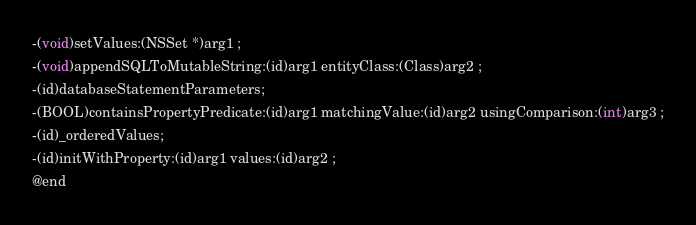<code> <loc_0><loc_0><loc_500><loc_500><_C_>-(void)setValues:(NSSet *)arg1 ;
-(void)appendSQLToMutableString:(id)arg1 entityClass:(Class)arg2 ;
-(id)databaseStatementParameters;
-(BOOL)containsPropertyPredicate:(id)arg1 matchingValue:(id)arg2 usingComparison:(int)arg3 ;
-(id)_orderedValues;
-(id)initWithProperty:(id)arg1 values:(id)arg2 ;
@end

</code> 